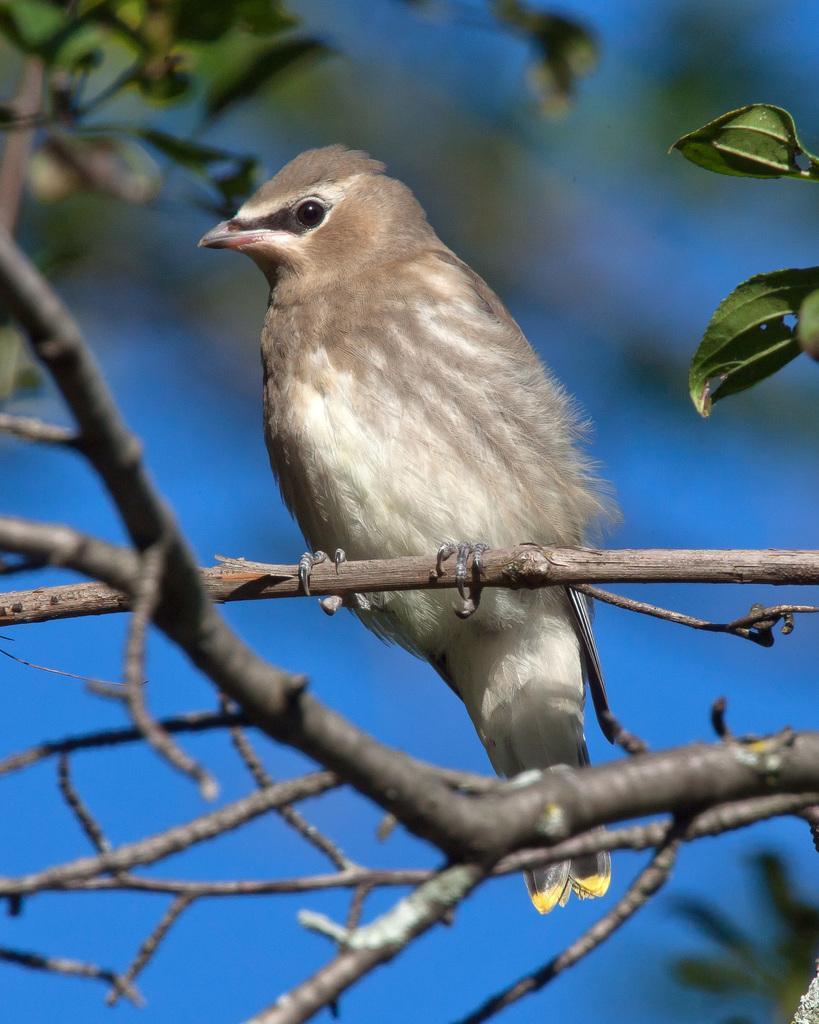In one or two sentences, can you explain what this image depicts? In this image we can see a bird on the tree branch. The background of the image is slightly blurred, where we can see the blue color sky. 